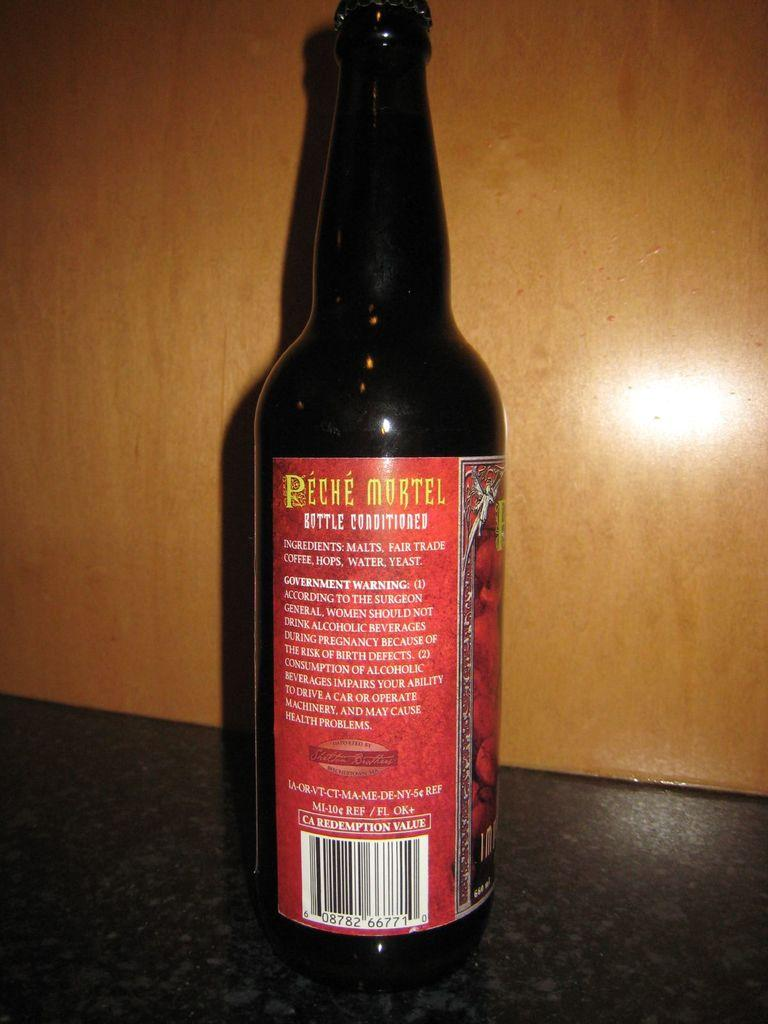<image>
Provide a brief description of the given image. A bottle of coffee infused alcoholic beverage is standing upright. 